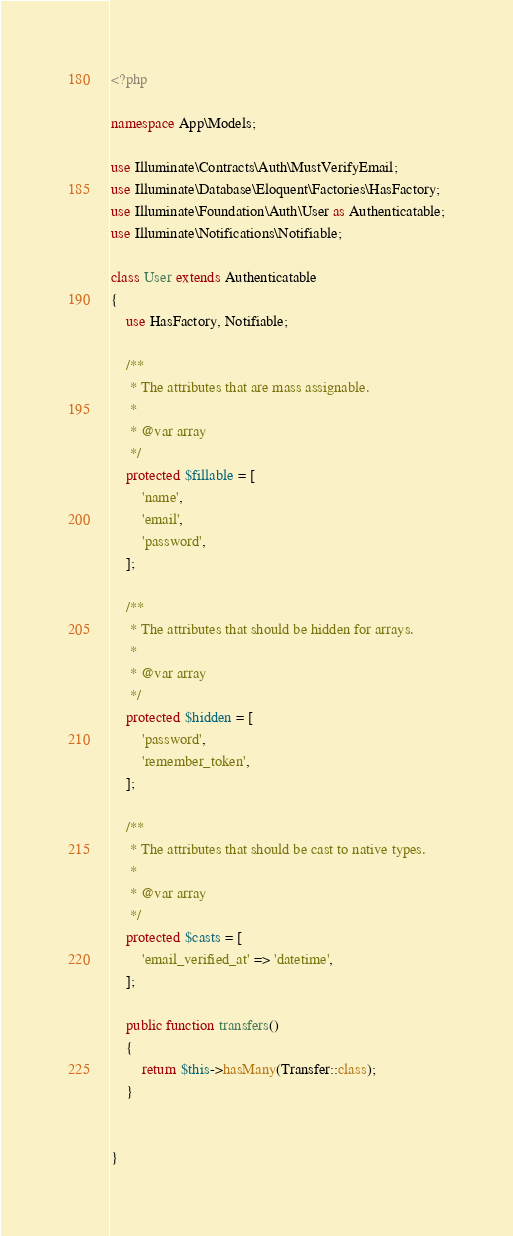Convert code to text. <code><loc_0><loc_0><loc_500><loc_500><_PHP_><?php

namespace App\Models;

use Illuminate\Contracts\Auth\MustVerifyEmail;
use Illuminate\Database\Eloquent\Factories\HasFactory;
use Illuminate\Foundation\Auth\User as Authenticatable;
use Illuminate\Notifications\Notifiable;

class User extends Authenticatable
{
    use HasFactory, Notifiable;

    /**
     * The attributes that are mass assignable.
     *
     * @var array
     */
    protected $fillable = [
        'name',
        'email',
        'password',
    ];

    /**
     * The attributes that should be hidden for arrays.
     *
     * @var array
     */
    protected $hidden = [
        'password',
        'remember_token',
    ];

    /**
     * The attributes that should be cast to native types.
     *
     * @var array
     */
    protected $casts = [
        'email_verified_at' => 'datetime',
    ];

    public function transfers()
    {
        return $this->hasMany(Transfer::class);
    }


}
</code> 